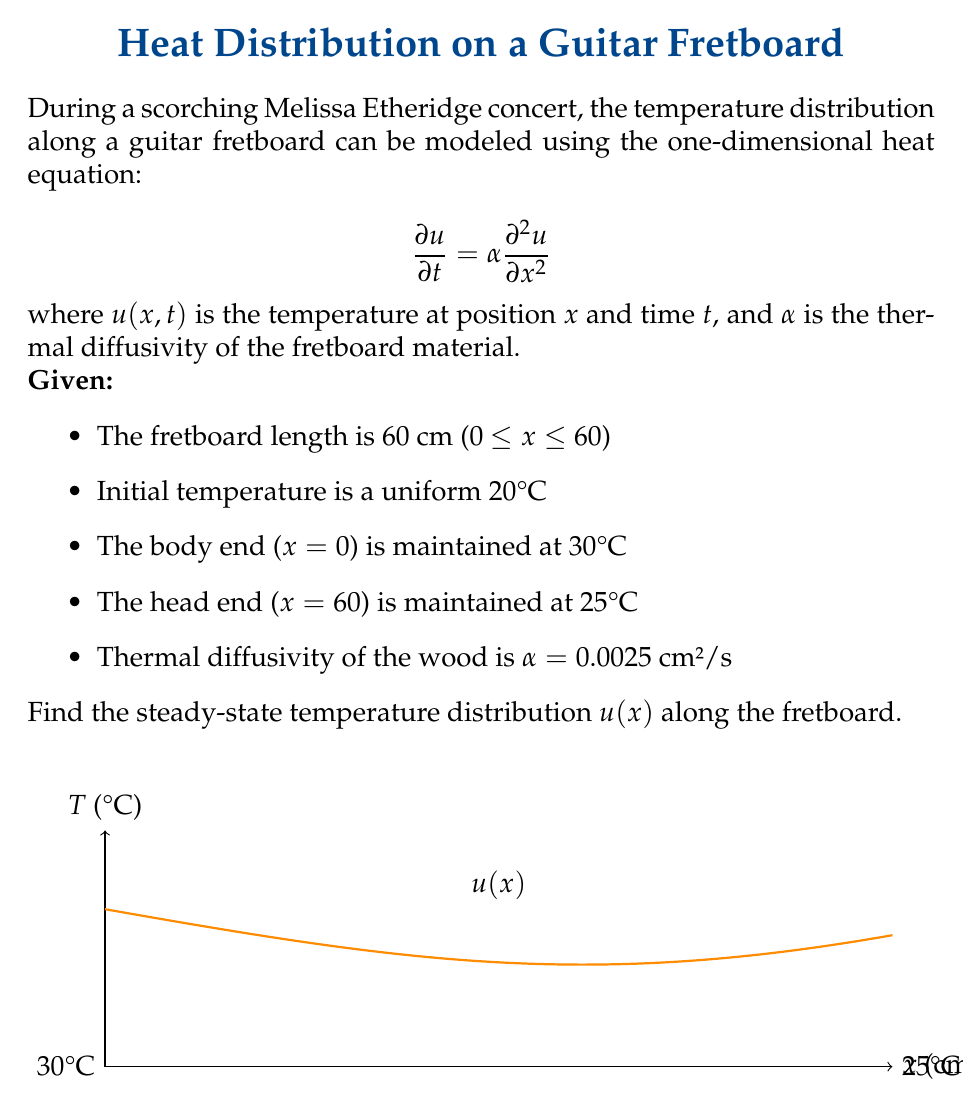Could you help me with this problem? To solve this problem, we'll follow these steps:

1) For the steady-state solution, $\frac{\partial u}{\partial t} = 0$, so the heat equation reduces to:

   $$0 = \alpha \frac{d^2 u}{dx^2}$$

2) This simplifies to:

   $$\frac{d^2 u}{dx^2} = 0$$

3) Integrating twice:

   $$\frac{du}{dx} = C_1$$
   $$u(x) = C_1x + C_2$$

4) We can determine $C_1$ and $C_2$ using the boundary conditions:

   At x = 0: $u(0) = 30$, so $C_2 = 30$
   At x = 60: $u(60) = 25$

5) Substituting these into the equation:

   $$25 = 60C_1 + 30$$

6) Solving for $C_1$:

   $$C_1 = \frac{25 - 30}{60} = -\frac{1}{12}$$

7) Therefore, the steady-state temperature distribution is:

   $$u(x) = -\frac{1}{12}x + 30$$

This linear function represents a gradual decrease in temperature from 30°C at the body end to 25°C at the head end of the fretboard.
Answer: $u(x) = -\frac{1}{12}x + 30$ 